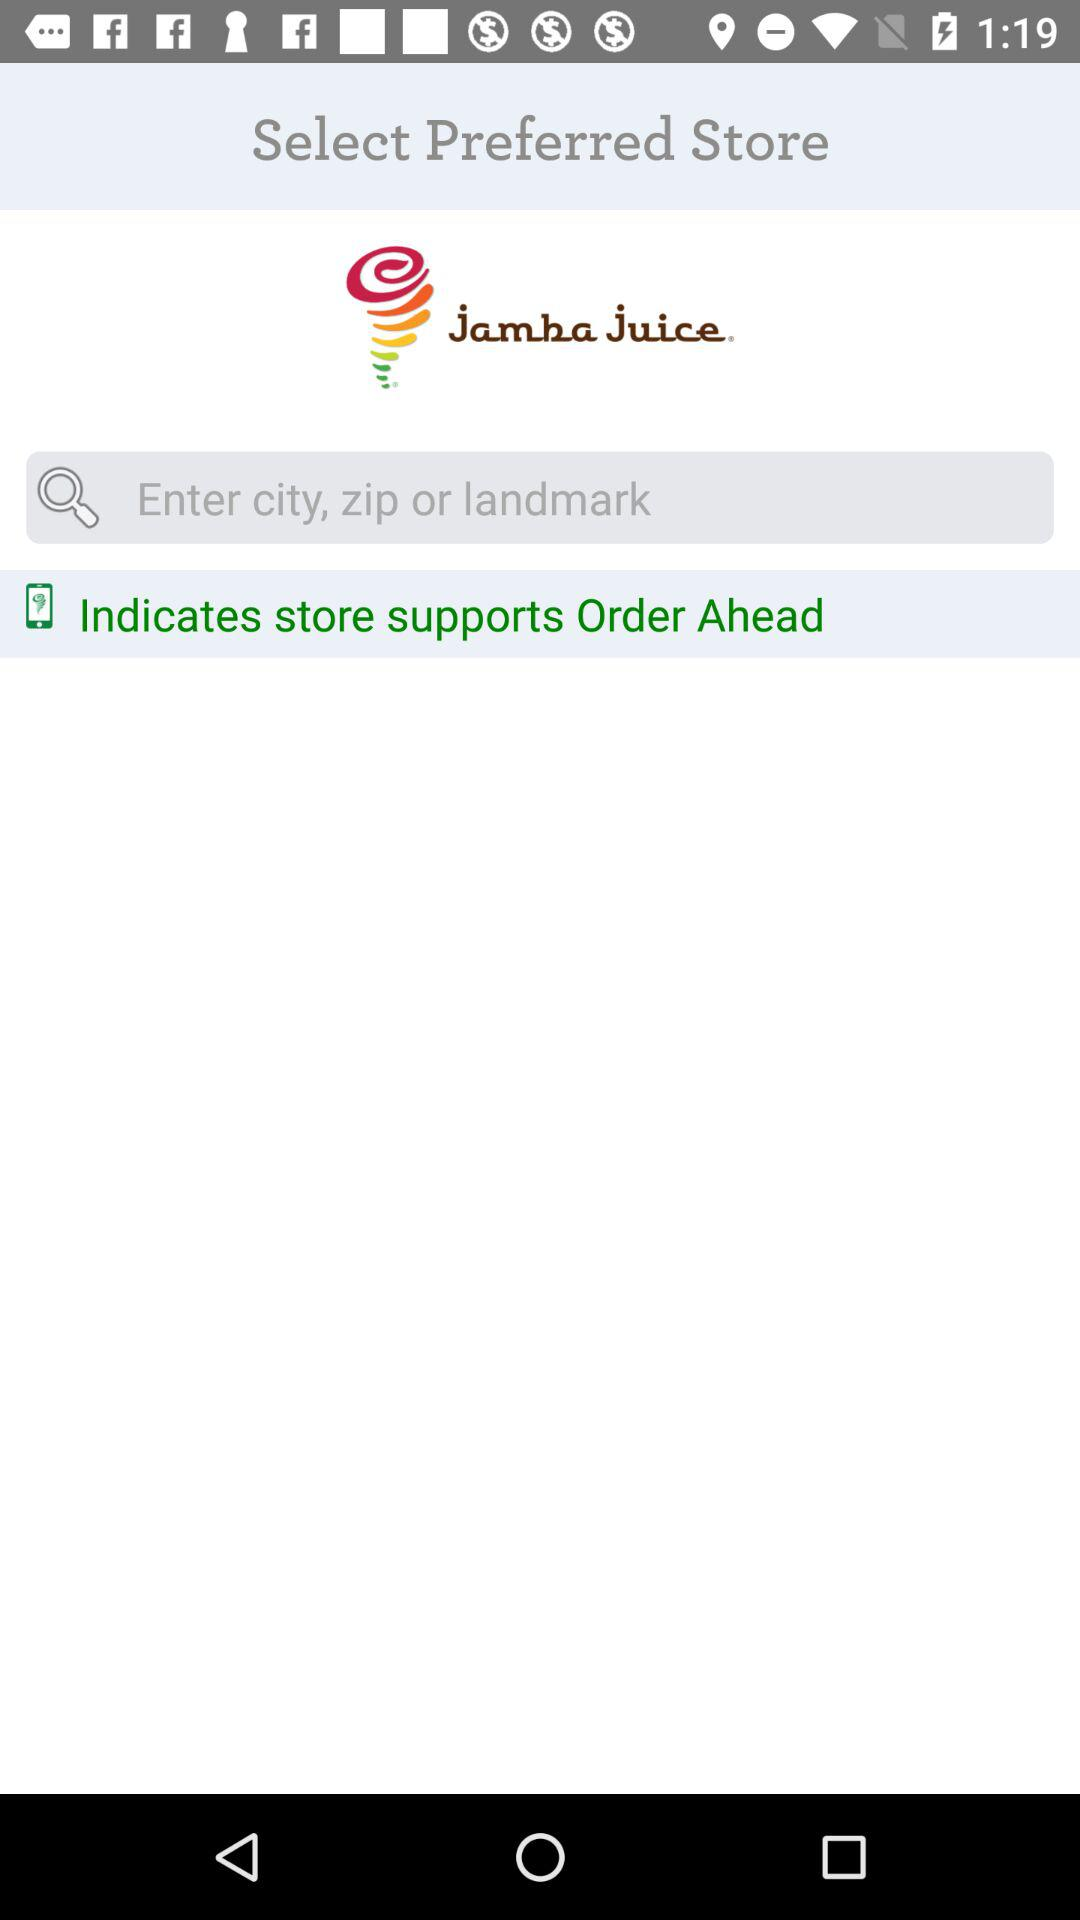Which preferred store has been selected?
When the provided information is insufficient, respond with <no answer>. <no answer> 